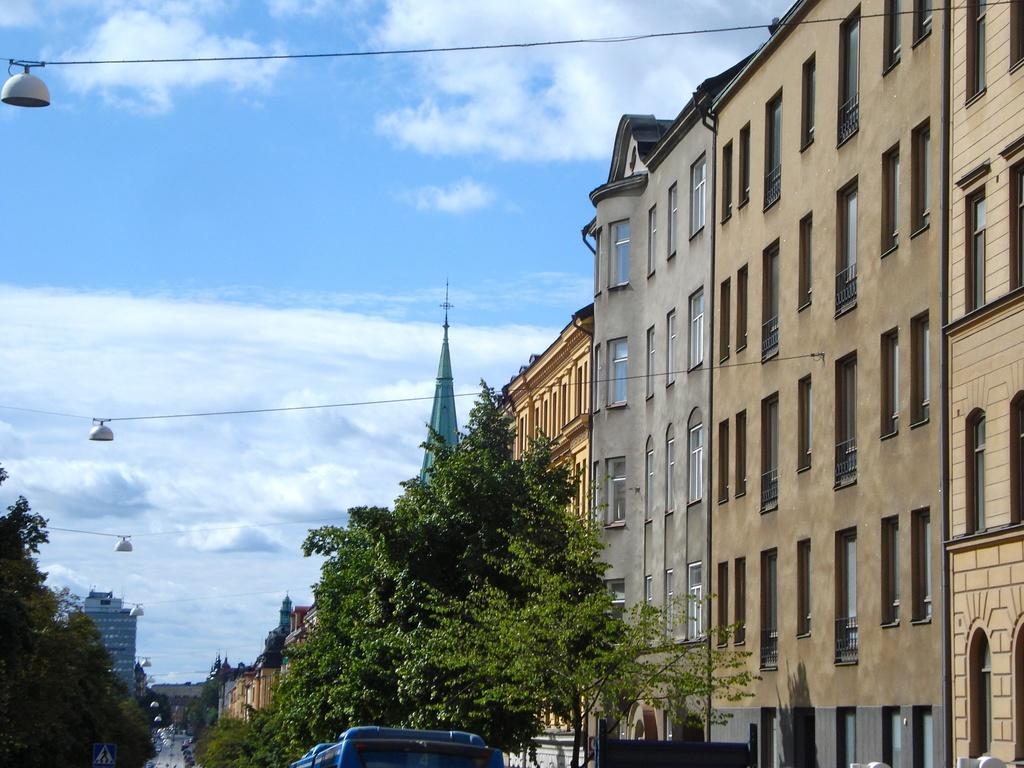Can you describe this image briefly? In this picture we can see trees and buildings. Behind the buildings, there is the sky. At the bottom of the image there are vehicles on the road and there is a signboard. On the left side of the image, those are looking like lights hanging to the cables. 